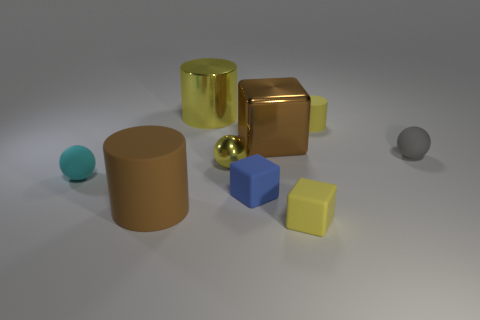What shapes are present in the arrangement, and can you tell me about their colors? In this arrangement, there are several geometric shapes present. We have a cylinder that is brown, a shiny gold cube and sphere, a matte blue cube, a smaller cyan sphere, and a yellow cube. Each object has a distinct color and shape, making for a visually interesting composition. 